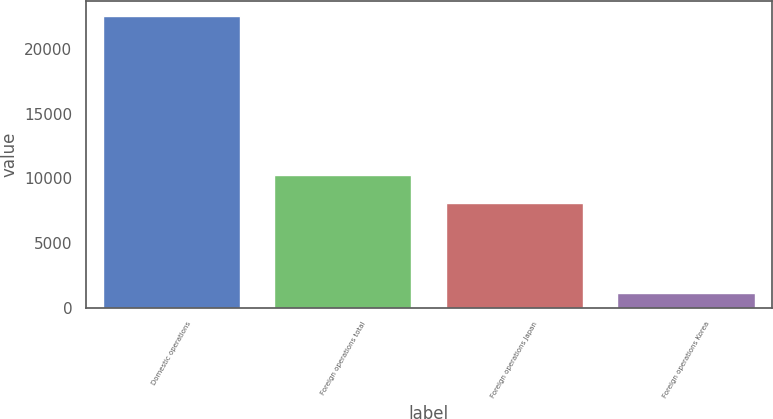Convert chart. <chart><loc_0><loc_0><loc_500><loc_500><bar_chart><fcel>Domestic operations<fcel>Foreign operations total<fcel>Foreign operations Japan<fcel>Foreign operations Korea<nl><fcel>22599<fcel>10232.2<fcel>8083<fcel>1107<nl></chart> 